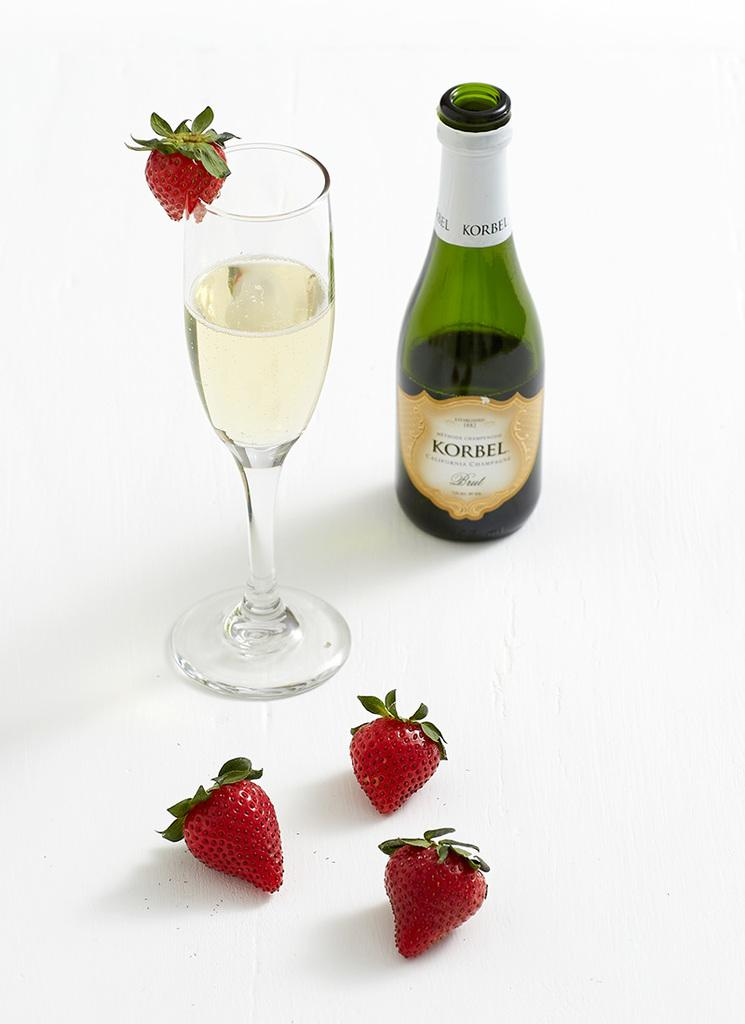What is in the glass that is visible in the image? There is a glass of wine in the image. What else can be seen in the image besides the glass of wine? There is a bottle and four strawberries visible in the image. Is there a flame coming out of the bottle in the image? No, there is no flame coming out of the bottle in the image. 